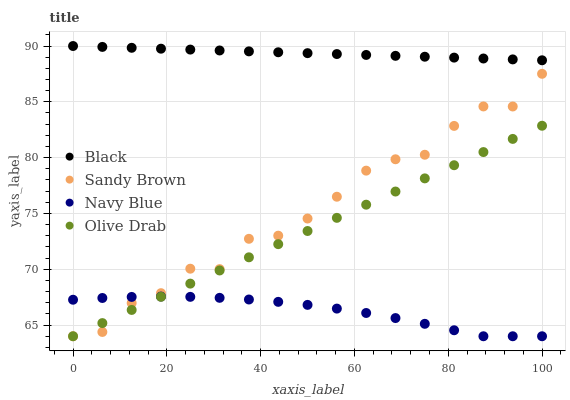Does Navy Blue have the minimum area under the curve?
Answer yes or no. Yes. Does Black have the maximum area under the curve?
Answer yes or no. Yes. Does Olive Drab have the minimum area under the curve?
Answer yes or no. No. Does Olive Drab have the maximum area under the curve?
Answer yes or no. No. Is Olive Drab the smoothest?
Answer yes or no. Yes. Is Sandy Brown the roughest?
Answer yes or no. Yes. Is Black the smoothest?
Answer yes or no. No. Is Black the roughest?
Answer yes or no. No. Does Sandy Brown have the lowest value?
Answer yes or no. Yes. Does Black have the lowest value?
Answer yes or no. No. Does Black have the highest value?
Answer yes or no. Yes. Does Olive Drab have the highest value?
Answer yes or no. No. Is Sandy Brown less than Black?
Answer yes or no. Yes. Is Black greater than Navy Blue?
Answer yes or no. Yes. Does Navy Blue intersect Olive Drab?
Answer yes or no. Yes. Is Navy Blue less than Olive Drab?
Answer yes or no. No. Is Navy Blue greater than Olive Drab?
Answer yes or no. No. Does Sandy Brown intersect Black?
Answer yes or no. No. 